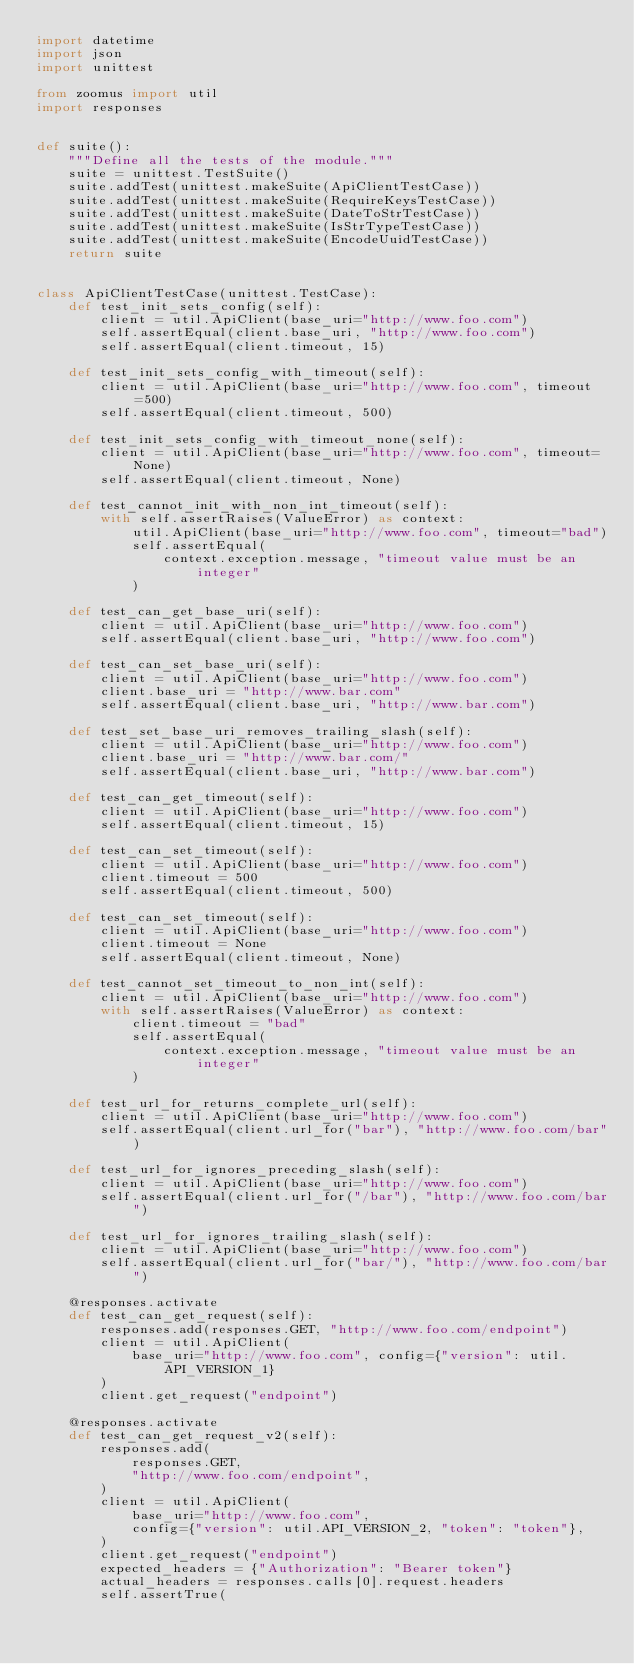<code> <loc_0><loc_0><loc_500><loc_500><_Python_>import datetime
import json
import unittest

from zoomus import util
import responses


def suite():
    """Define all the tests of the module."""
    suite = unittest.TestSuite()
    suite.addTest(unittest.makeSuite(ApiClientTestCase))
    suite.addTest(unittest.makeSuite(RequireKeysTestCase))
    suite.addTest(unittest.makeSuite(DateToStrTestCase))
    suite.addTest(unittest.makeSuite(IsStrTypeTestCase))
    suite.addTest(unittest.makeSuite(EncodeUuidTestCase))
    return suite


class ApiClientTestCase(unittest.TestCase):
    def test_init_sets_config(self):
        client = util.ApiClient(base_uri="http://www.foo.com")
        self.assertEqual(client.base_uri, "http://www.foo.com")
        self.assertEqual(client.timeout, 15)

    def test_init_sets_config_with_timeout(self):
        client = util.ApiClient(base_uri="http://www.foo.com", timeout=500)
        self.assertEqual(client.timeout, 500)

    def test_init_sets_config_with_timeout_none(self):
        client = util.ApiClient(base_uri="http://www.foo.com", timeout=None)
        self.assertEqual(client.timeout, None)

    def test_cannot_init_with_non_int_timeout(self):
        with self.assertRaises(ValueError) as context:
            util.ApiClient(base_uri="http://www.foo.com", timeout="bad")
            self.assertEqual(
                context.exception.message, "timeout value must be an integer"
            )

    def test_can_get_base_uri(self):
        client = util.ApiClient(base_uri="http://www.foo.com")
        self.assertEqual(client.base_uri, "http://www.foo.com")

    def test_can_set_base_uri(self):
        client = util.ApiClient(base_uri="http://www.foo.com")
        client.base_uri = "http://www.bar.com"
        self.assertEqual(client.base_uri, "http://www.bar.com")

    def test_set_base_uri_removes_trailing_slash(self):
        client = util.ApiClient(base_uri="http://www.foo.com")
        client.base_uri = "http://www.bar.com/"
        self.assertEqual(client.base_uri, "http://www.bar.com")

    def test_can_get_timeout(self):
        client = util.ApiClient(base_uri="http://www.foo.com")
        self.assertEqual(client.timeout, 15)

    def test_can_set_timeout(self):
        client = util.ApiClient(base_uri="http://www.foo.com")
        client.timeout = 500
        self.assertEqual(client.timeout, 500)

    def test_can_set_timeout(self):
        client = util.ApiClient(base_uri="http://www.foo.com")
        client.timeout = None
        self.assertEqual(client.timeout, None)

    def test_cannot_set_timeout_to_non_int(self):
        client = util.ApiClient(base_uri="http://www.foo.com")
        with self.assertRaises(ValueError) as context:
            client.timeout = "bad"
            self.assertEqual(
                context.exception.message, "timeout value must be an integer"
            )

    def test_url_for_returns_complete_url(self):
        client = util.ApiClient(base_uri="http://www.foo.com")
        self.assertEqual(client.url_for("bar"), "http://www.foo.com/bar")

    def test_url_for_ignores_preceding_slash(self):
        client = util.ApiClient(base_uri="http://www.foo.com")
        self.assertEqual(client.url_for("/bar"), "http://www.foo.com/bar")

    def test_url_for_ignores_trailing_slash(self):
        client = util.ApiClient(base_uri="http://www.foo.com")
        self.assertEqual(client.url_for("bar/"), "http://www.foo.com/bar")

    @responses.activate
    def test_can_get_request(self):
        responses.add(responses.GET, "http://www.foo.com/endpoint")
        client = util.ApiClient(
            base_uri="http://www.foo.com", config={"version": util.API_VERSION_1}
        )
        client.get_request("endpoint")

    @responses.activate
    def test_can_get_request_v2(self):
        responses.add(
            responses.GET,
            "http://www.foo.com/endpoint",
        )
        client = util.ApiClient(
            base_uri="http://www.foo.com",
            config={"version": util.API_VERSION_2, "token": "token"},
        )
        client.get_request("endpoint")
        expected_headers = {"Authorization": "Bearer token"}
        actual_headers = responses.calls[0].request.headers
        self.assertTrue(</code> 